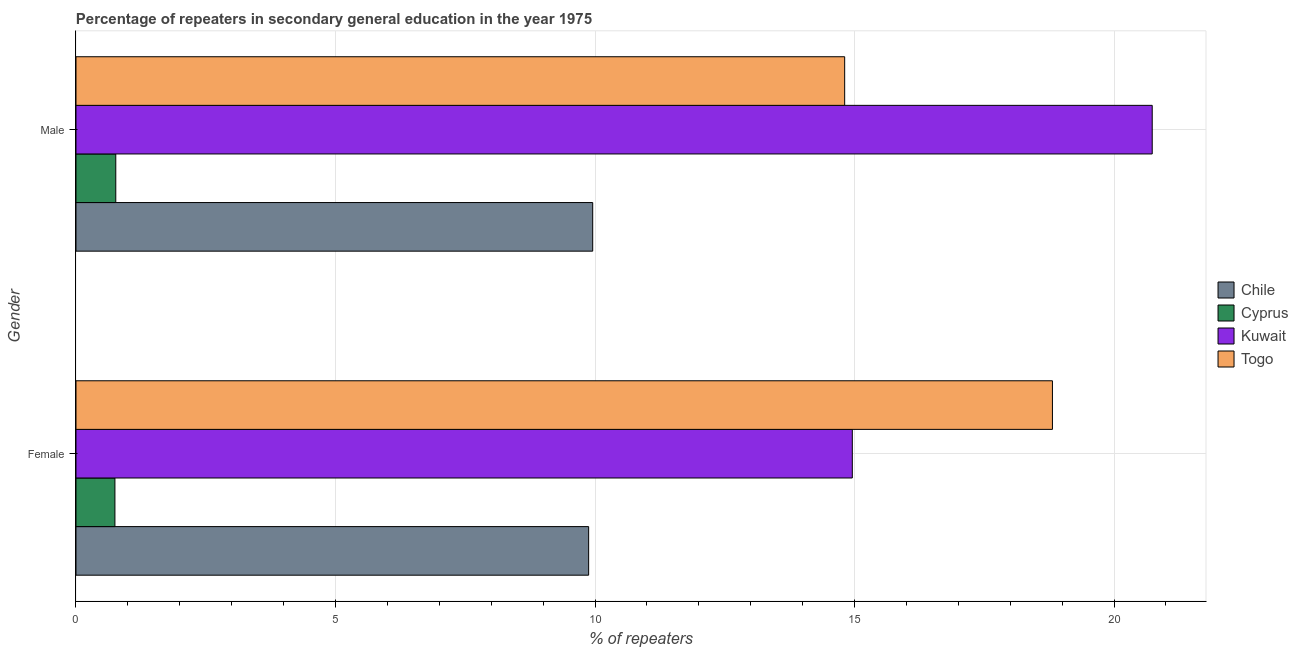How many different coloured bars are there?
Your response must be concise. 4. How many groups of bars are there?
Provide a succinct answer. 2. Are the number of bars on each tick of the Y-axis equal?
Give a very brief answer. Yes. What is the percentage of male repeaters in Cyprus?
Offer a very short reply. 0.77. Across all countries, what is the maximum percentage of male repeaters?
Offer a very short reply. 20.74. Across all countries, what is the minimum percentage of female repeaters?
Make the answer very short. 0.75. In which country was the percentage of female repeaters maximum?
Provide a short and direct response. Togo. In which country was the percentage of male repeaters minimum?
Your answer should be very brief. Cyprus. What is the total percentage of male repeaters in the graph?
Your response must be concise. 46.27. What is the difference between the percentage of male repeaters in Chile and that in Kuwait?
Your answer should be compact. -10.78. What is the difference between the percentage of female repeaters in Kuwait and the percentage of male repeaters in Togo?
Give a very brief answer. 0.15. What is the average percentage of female repeaters per country?
Your response must be concise. 11.1. What is the difference between the percentage of female repeaters and percentage of male repeaters in Cyprus?
Make the answer very short. -0.02. In how many countries, is the percentage of female repeaters greater than 7 %?
Your response must be concise. 3. What is the ratio of the percentage of male repeaters in Kuwait to that in Chile?
Offer a very short reply. 2.08. What does the 3rd bar from the top in Female represents?
Provide a short and direct response. Cyprus. What does the 3rd bar from the bottom in Male represents?
Give a very brief answer. Kuwait. How many bars are there?
Your answer should be compact. 8. What is the difference between two consecutive major ticks on the X-axis?
Provide a succinct answer. 5. Does the graph contain grids?
Offer a terse response. Yes. What is the title of the graph?
Your answer should be very brief. Percentage of repeaters in secondary general education in the year 1975. What is the label or title of the X-axis?
Provide a short and direct response. % of repeaters. What is the % of repeaters in Chile in Female?
Keep it short and to the point. 9.88. What is the % of repeaters of Kuwait in Female?
Make the answer very short. 14.96. What is the % of repeaters in Togo in Female?
Your answer should be compact. 18.81. What is the % of repeaters of Chile in Male?
Your answer should be compact. 9.96. What is the % of repeaters of Cyprus in Male?
Your response must be concise. 0.77. What is the % of repeaters of Kuwait in Male?
Your response must be concise. 20.74. What is the % of repeaters in Togo in Male?
Give a very brief answer. 14.81. Across all Gender, what is the maximum % of repeaters in Chile?
Offer a terse response. 9.96. Across all Gender, what is the maximum % of repeaters in Cyprus?
Keep it short and to the point. 0.77. Across all Gender, what is the maximum % of repeaters of Kuwait?
Give a very brief answer. 20.74. Across all Gender, what is the maximum % of repeaters in Togo?
Ensure brevity in your answer.  18.81. Across all Gender, what is the minimum % of repeaters of Chile?
Provide a succinct answer. 9.88. Across all Gender, what is the minimum % of repeaters in Cyprus?
Make the answer very short. 0.75. Across all Gender, what is the minimum % of repeaters in Kuwait?
Your response must be concise. 14.96. Across all Gender, what is the minimum % of repeaters in Togo?
Make the answer very short. 14.81. What is the total % of repeaters of Chile in the graph?
Your response must be concise. 19.83. What is the total % of repeaters of Cyprus in the graph?
Keep it short and to the point. 1.52. What is the total % of repeaters of Kuwait in the graph?
Keep it short and to the point. 35.69. What is the total % of repeaters in Togo in the graph?
Provide a short and direct response. 33.62. What is the difference between the % of repeaters in Chile in Female and that in Male?
Your answer should be very brief. -0.08. What is the difference between the % of repeaters of Cyprus in Female and that in Male?
Offer a terse response. -0.02. What is the difference between the % of repeaters of Kuwait in Female and that in Male?
Your response must be concise. -5.78. What is the difference between the % of repeaters of Togo in Female and that in Male?
Your response must be concise. 4. What is the difference between the % of repeaters of Chile in Female and the % of repeaters of Cyprus in Male?
Provide a succinct answer. 9.11. What is the difference between the % of repeaters of Chile in Female and the % of repeaters of Kuwait in Male?
Ensure brevity in your answer.  -10.86. What is the difference between the % of repeaters in Chile in Female and the % of repeaters in Togo in Male?
Offer a terse response. -4.93. What is the difference between the % of repeaters in Cyprus in Female and the % of repeaters in Kuwait in Male?
Offer a terse response. -19.99. What is the difference between the % of repeaters in Cyprus in Female and the % of repeaters in Togo in Male?
Make the answer very short. -14.06. What is the difference between the % of repeaters in Kuwait in Female and the % of repeaters in Togo in Male?
Provide a succinct answer. 0.15. What is the average % of repeaters in Chile per Gender?
Your answer should be compact. 9.92. What is the average % of repeaters of Cyprus per Gender?
Provide a short and direct response. 0.76. What is the average % of repeaters in Kuwait per Gender?
Your response must be concise. 17.85. What is the average % of repeaters in Togo per Gender?
Provide a succinct answer. 16.81. What is the difference between the % of repeaters in Chile and % of repeaters in Cyprus in Female?
Your response must be concise. 9.13. What is the difference between the % of repeaters of Chile and % of repeaters of Kuwait in Female?
Your answer should be compact. -5.08. What is the difference between the % of repeaters of Chile and % of repeaters of Togo in Female?
Provide a succinct answer. -8.94. What is the difference between the % of repeaters in Cyprus and % of repeaters in Kuwait in Female?
Offer a terse response. -14.21. What is the difference between the % of repeaters of Cyprus and % of repeaters of Togo in Female?
Your answer should be very brief. -18.06. What is the difference between the % of repeaters of Kuwait and % of repeaters of Togo in Female?
Your answer should be very brief. -3.86. What is the difference between the % of repeaters of Chile and % of repeaters of Cyprus in Male?
Ensure brevity in your answer.  9.19. What is the difference between the % of repeaters of Chile and % of repeaters of Kuwait in Male?
Provide a succinct answer. -10.78. What is the difference between the % of repeaters of Chile and % of repeaters of Togo in Male?
Offer a terse response. -4.85. What is the difference between the % of repeaters of Cyprus and % of repeaters of Kuwait in Male?
Your answer should be compact. -19.97. What is the difference between the % of repeaters in Cyprus and % of repeaters in Togo in Male?
Your answer should be very brief. -14.04. What is the difference between the % of repeaters in Kuwait and % of repeaters in Togo in Male?
Provide a succinct answer. 5.93. What is the ratio of the % of repeaters of Chile in Female to that in Male?
Your answer should be compact. 0.99. What is the ratio of the % of repeaters in Cyprus in Female to that in Male?
Your answer should be very brief. 0.98. What is the ratio of the % of repeaters in Kuwait in Female to that in Male?
Ensure brevity in your answer.  0.72. What is the ratio of the % of repeaters of Togo in Female to that in Male?
Keep it short and to the point. 1.27. What is the difference between the highest and the second highest % of repeaters of Chile?
Make the answer very short. 0.08. What is the difference between the highest and the second highest % of repeaters of Cyprus?
Make the answer very short. 0.02. What is the difference between the highest and the second highest % of repeaters in Kuwait?
Ensure brevity in your answer.  5.78. What is the difference between the highest and the second highest % of repeaters in Togo?
Keep it short and to the point. 4. What is the difference between the highest and the lowest % of repeaters in Chile?
Your answer should be very brief. 0.08. What is the difference between the highest and the lowest % of repeaters of Cyprus?
Make the answer very short. 0.02. What is the difference between the highest and the lowest % of repeaters in Kuwait?
Give a very brief answer. 5.78. What is the difference between the highest and the lowest % of repeaters in Togo?
Make the answer very short. 4. 